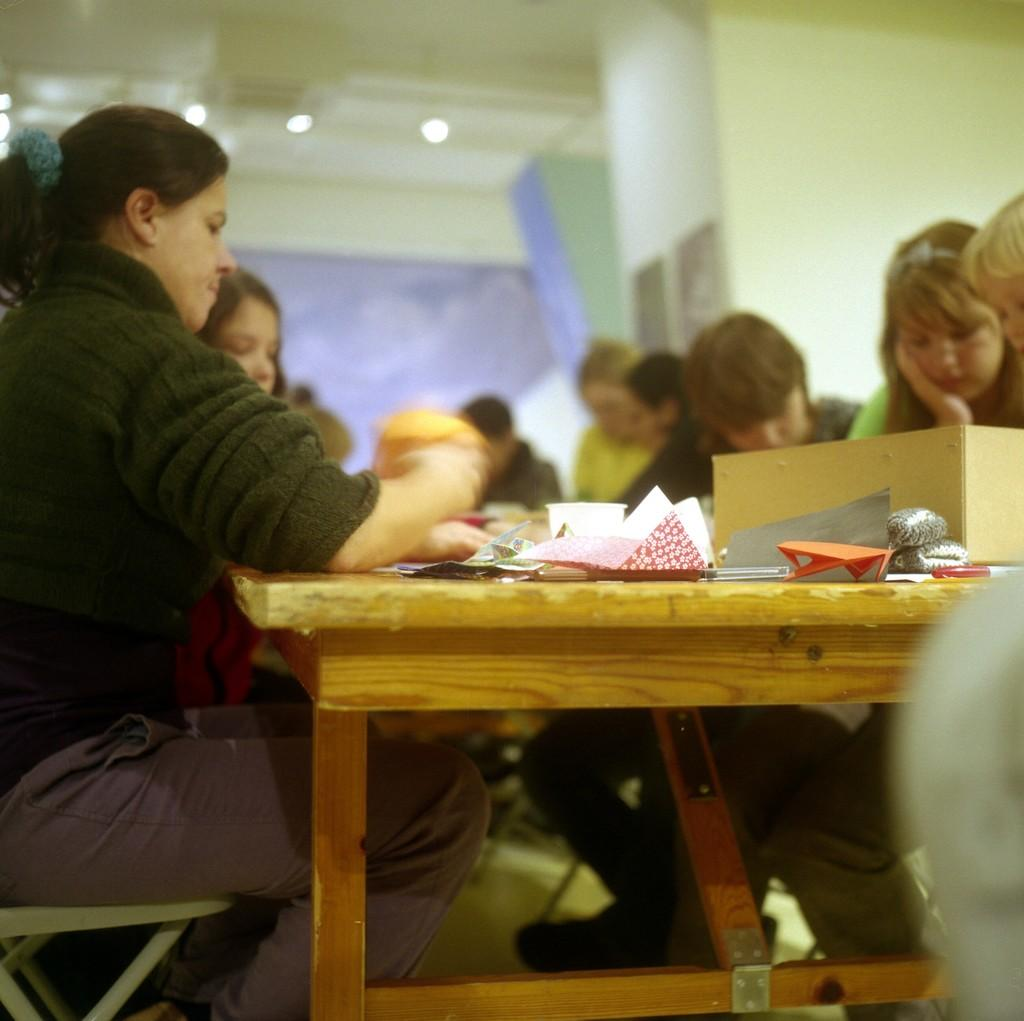What are the people in the image doing? The people in the image are sitting on chairs. Where are the chairs located in relation to the table? The chairs are near a table. What can be seen on the table in the image? There are things placed on the table. What does the notebook smell like in the image? There is no notebook present in the image, so it cannot be determined what it might smell like. 